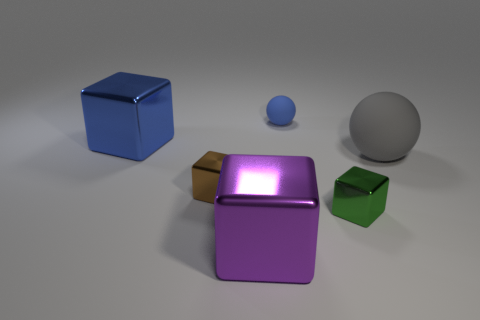There is another block that is the same size as the green metallic block; what is its material?
Offer a very short reply. Metal. There is a ball that is in front of the blue matte ball; does it have the same size as the small brown object?
Your answer should be compact. No. How many spheres are small matte things or purple shiny objects?
Your answer should be compact. 1. There is a large block behind the brown block; what is it made of?
Ensure brevity in your answer.  Metal. Is the number of cylinders less than the number of small brown metallic things?
Provide a succinct answer. Yes. What is the size of the shiny cube that is both to the left of the small green object and right of the brown metallic block?
Make the answer very short. Large. There is a green object in front of the matte object on the left side of the ball on the right side of the tiny green shiny object; how big is it?
Your answer should be very brief. Small. What number of other things are the same color as the large rubber ball?
Your answer should be very brief. 0. There is a metal object behind the big gray rubber ball; does it have the same color as the small sphere?
Keep it short and to the point. Yes. What number of things are either green shiny things or small shiny cubes?
Your response must be concise. 2. 